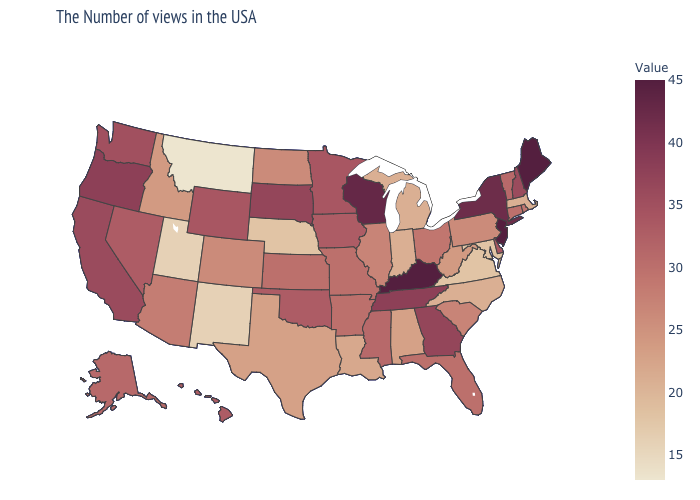Does Massachusetts have a higher value than Montana?
Write a very short answer. Yes. Does Iowa have the highest value in the MidWest?
Write a very short answer. No. Is the legend a continuous bar?
Quick response, please. Yes. 